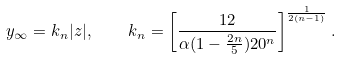<formula> <loc_0><loc_0><loc_500><loc_500>y _ { \infty } = k _ { n } | z | , \quad k _ { n } = \left [ \frac { 1 2 } { \alpha ( 1 - \frac { 2 n } { 5 } ) 2 0 ^ { n } } \right ] ^ { \frac { 1 } { 2 ( n - 1 ) } } .</formula> 